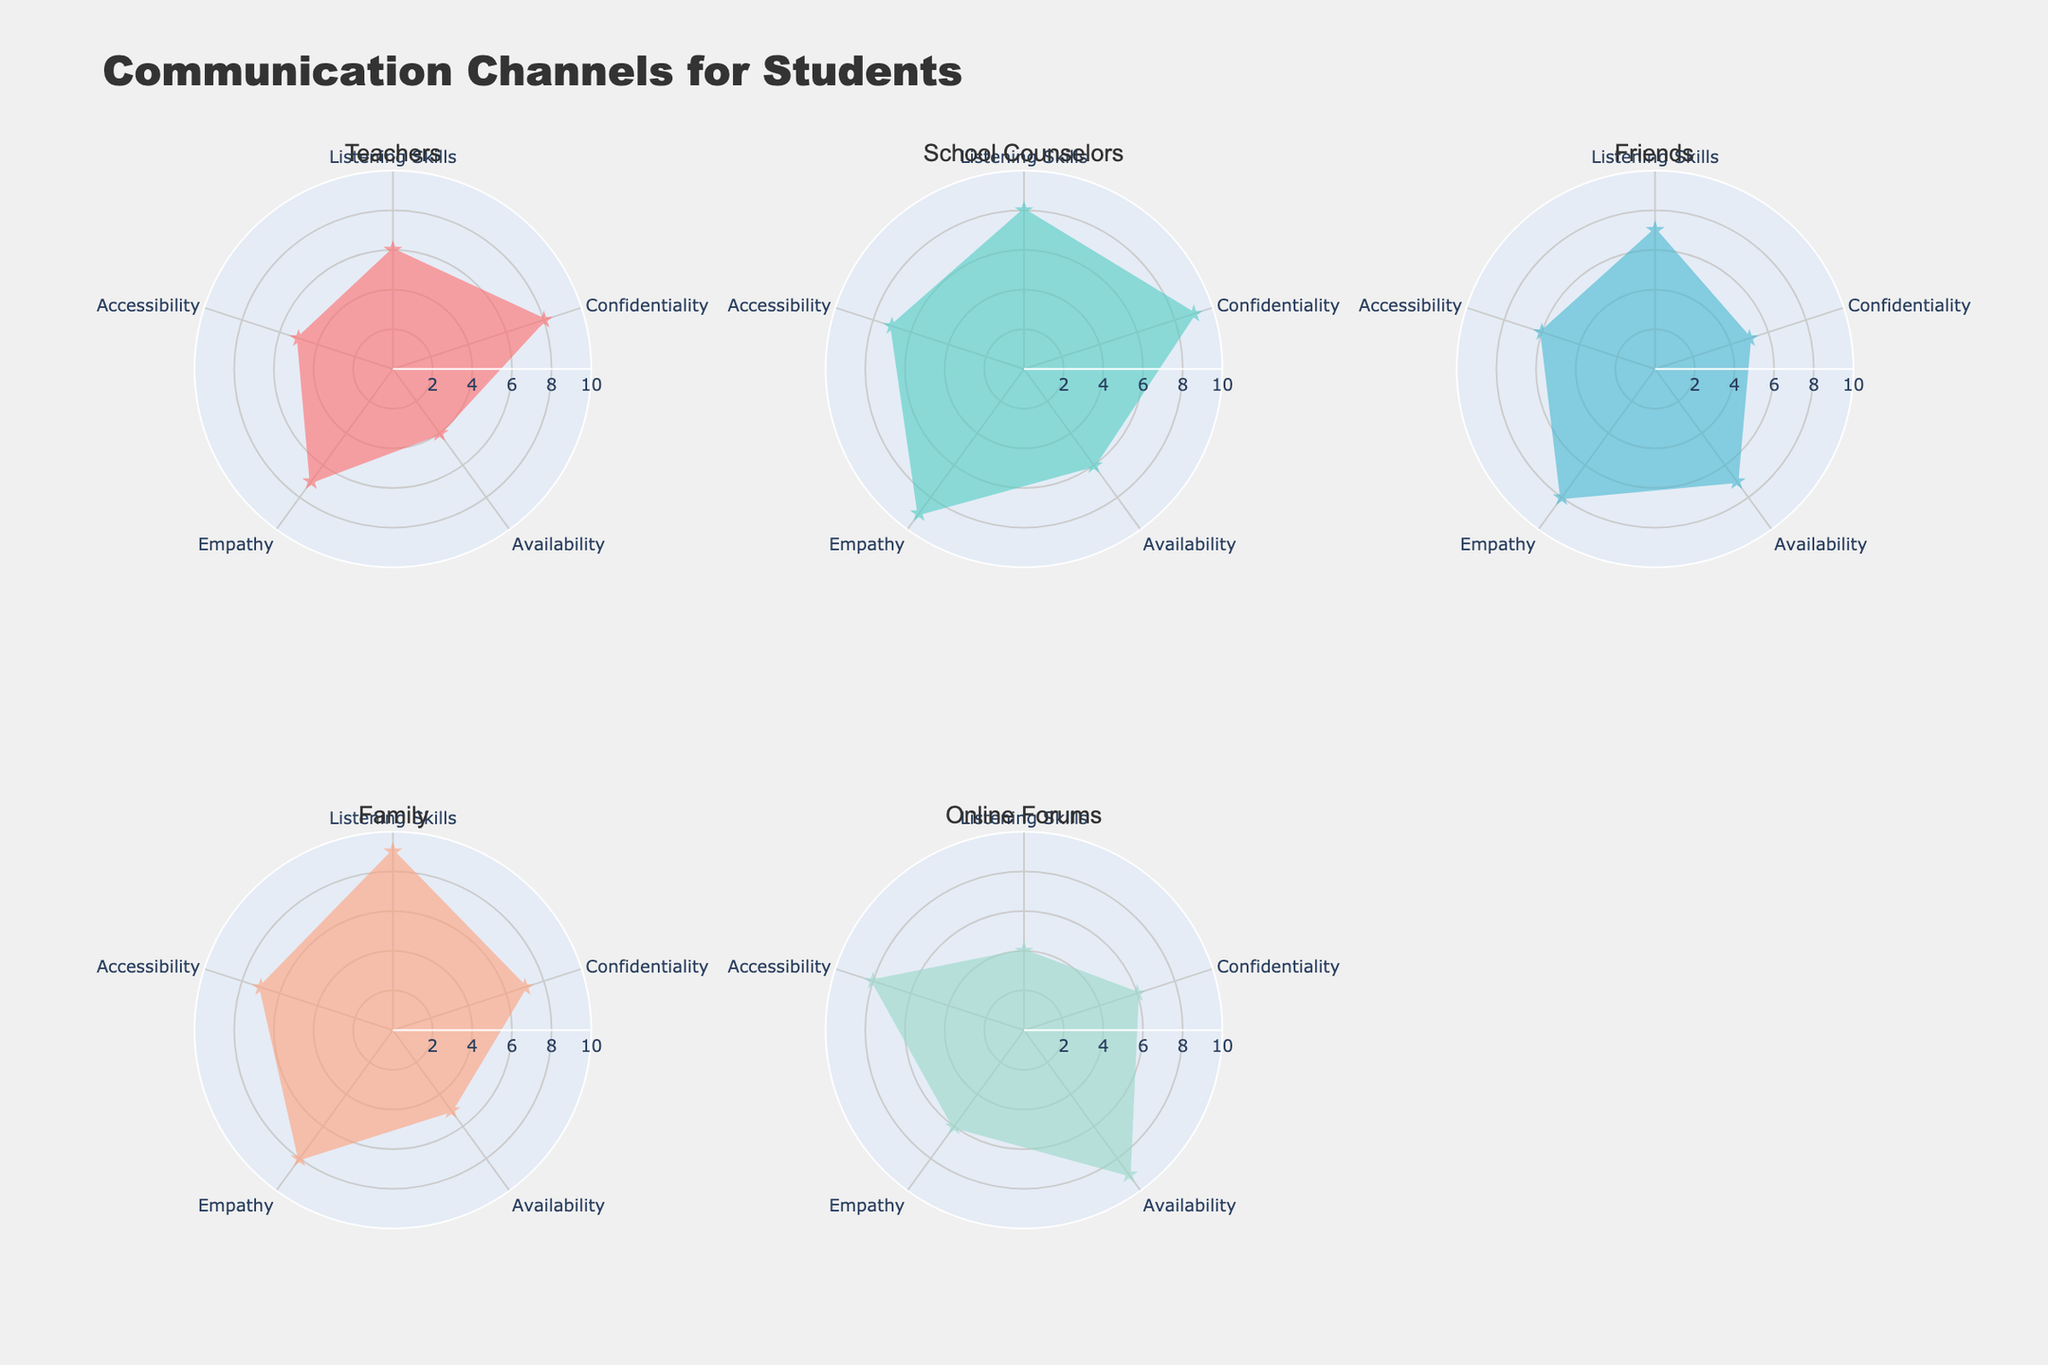What is the highest score for Listening Skills? By looking at the radial axis labeled "Listening Skills," the highest score can be found by comparing the values across all the channels. The maximum score is 9.
Answer: 9 Which channel has the lowest score for Accessibility? Observe the "Accessibility" axis and compare the values for each channel. The lowest score is 5, which belongs to Teachers.
Answer: Teachers What is the average score of School Counselors for all criteria? Add the scores for School Counselors (8 + 9 + 6 + 9 + 7) and divide by the number of criteria (5). The average is (8 + 9 + 6 + 9 + 7) / 5 = 39 / 5.
Answer: 7.8 In which criterion does Online Forums outperform Family? Compare each criterion where Online Forums' values are greater than those for Family. Online Forums scores higher in Availability (9 > 5).
Answer: Availability Which channel has the most balanced scores across all criteria? Identify the channel with the least variability in scores. Family has scores that are more uniform: 9, 7, 5, 8, 7.
Answer: Family How does the Empathy score for Teachers compare to that of Friends? Check the "Empathy" axis and compare the scores for Teachers (7) and Friends (8). Friends have a higher score.
Answer: Friends What is the sum of all scores for Friends? Add the scores for Friends (7 + 5 + 7 + 8 + 6). The sum is 7 + 5 + 7 + 8 + 6 = 33.
Answer: 33 Which channel has the highest average score for Listening Skills and Empathy? Calculate the average of Listening Skills and Empathy for each channel and find the highest. Scores are: Teachers (6+7)/2 = 6.5, School Counselors (8+9)/2 = 8.5, Friends (7+8)/2 = 7.5, Family (9+8)/2 = 8.5, Online Forums (4+6)/2 = 5. School Counselors and Family have the highest average.
Answer: School Counselors, Family Which channel has the lowest score in any single criterion? Look for the minimum value in any criterion across all channels. Online Forums have 4 in Listening Skills.
Answer: Online Forums Compare the Availability scores for Teachers and School Counselors. Check the "Availability" scores for Teachers (4) and School Counselors (6). School Counselors have the higher score.
Answer: School Counselors 